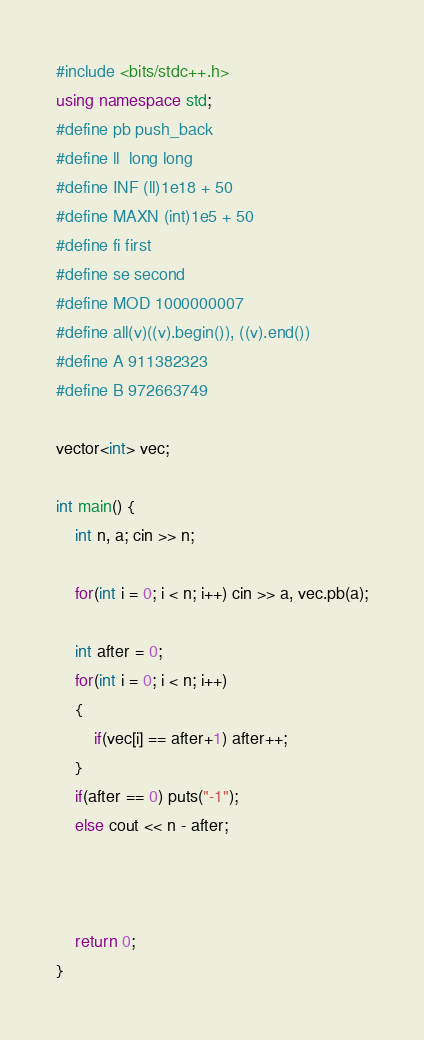<code> <loc_0><loc_0><loc_500><loc_500><_C++_>#include <bits/stdc++.h>
using namespace std;
#define pb push_back
#define ll  long long
#define INF (ll)1e18 + 50
#define MAXN (int)1e5 + 50
#define fi first
#define se second
#define MOD 1000000007
#define all(v)((v).begin()), ((v).end())
#define A 911382323
#define B 972663749

vector<int> vec;

int main() {
    int n, a; cin >> n;
    
    for(int i = 0; i < n; i++) cin >> a, vec.pb(a);
	
	int after = 0;
	for(int i = 0; i < n; i++)
	{
		if(vec[i] == after+1) after++;
	}
	if(after == 0) puts("-1");
	else cout << n - after;
	


    return 0;
}</code> 